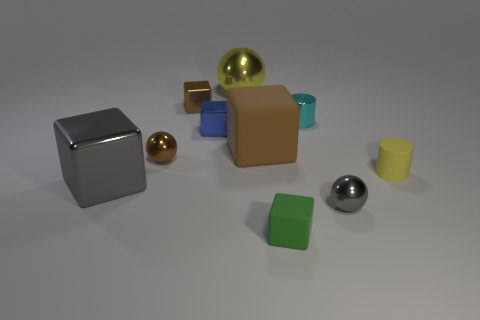Subtract all tiny balls. How many balls are left? 1 Subtract all red cylinders. How many brown blocks are left? 2 Subtract all gray cubes. How many cubes are left? 4 Subtract 3 cubes. How many cubes are left? 2 Add 6 tiny green matte objects. How many tiny green matte objects are left? 7 Add 1 brown things. How many brown things exist? 4 Subtract 0 brown cylinders. How many objects are left? 10 Subtract all balls. How many objects are left? 7 Subtract all red cubes. Subtract all purple spheres. How many cubes are left? 5 Subtract all small blue things. Subtract all gray metal things. How many objects are left? 7 